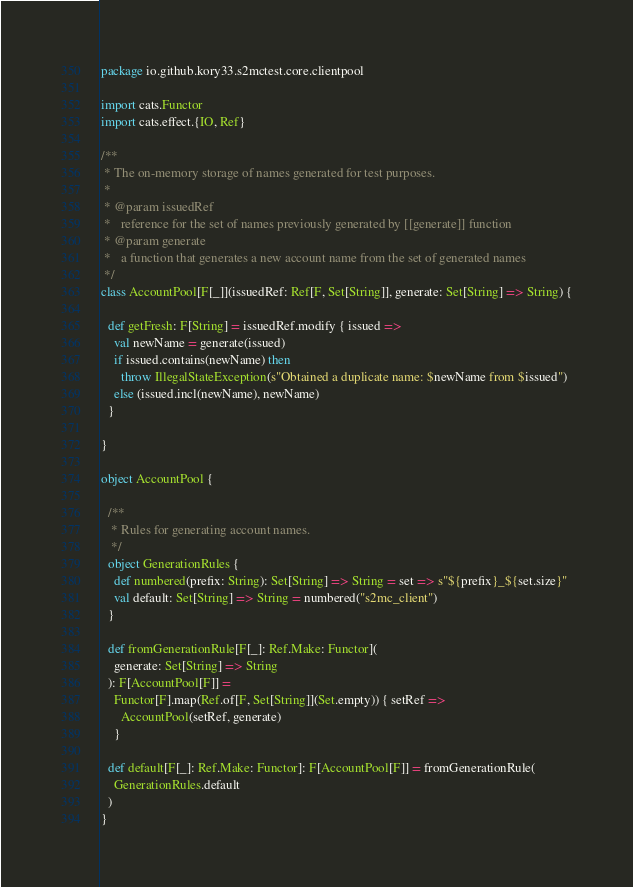Convert code to text. <code><loc_0><loc_0><loc_500><loc_500><_Scala_>package io.github.kory33.s2mctest.core.clientpool

import cats.Functor
import cats.effect.{IO, Ref}

/**
 * The on-memory storage of names generated for test purposes.
 *
 * @param issuedRef
 *   reference for the set of names previously generated by [[generate]] function
 * @param generate
 *   a function that generates a new account name from the set of generated names
 */
class AccountPool[F[_]](issuedRef: Ref[F, Set[String]], generate: Set[String] => String) {

  def getFresh: F[String] = issuedRef.modify { issued =>
    val newName = generate(issued)
    if issued.contains(newName) then
      throw IllegalStateException(s"Obtained a duplicate name: $newName from $issued")
    else (issued.incl(newName), newName)
  }

}

object AccountPool {

  /**
   * Rules for generating account names.
   */
  object GenerationRules {
    def numbered(prefix: String): Set[String] => String = set => s"${prefix}_${set.size}"
    val default: Set[String] => String = numbered("s2mc_client")
  }

  def fromGenerationRule[F[_]: Ref.Make: Functor](
    generate: Set[String] => String
  ): F[AccountPool[F]] =
    Functor[F].map(Ref.of[F, Set[String]](Set.empty)) { setRef =>
      AccountPool(setRef, generate)
    }

  def default[F[_]: Ref.Make: Functor]: F[AccountPool[F]] = fromGenerationRule(
    GenerationRules.default
  )
}
</code> 